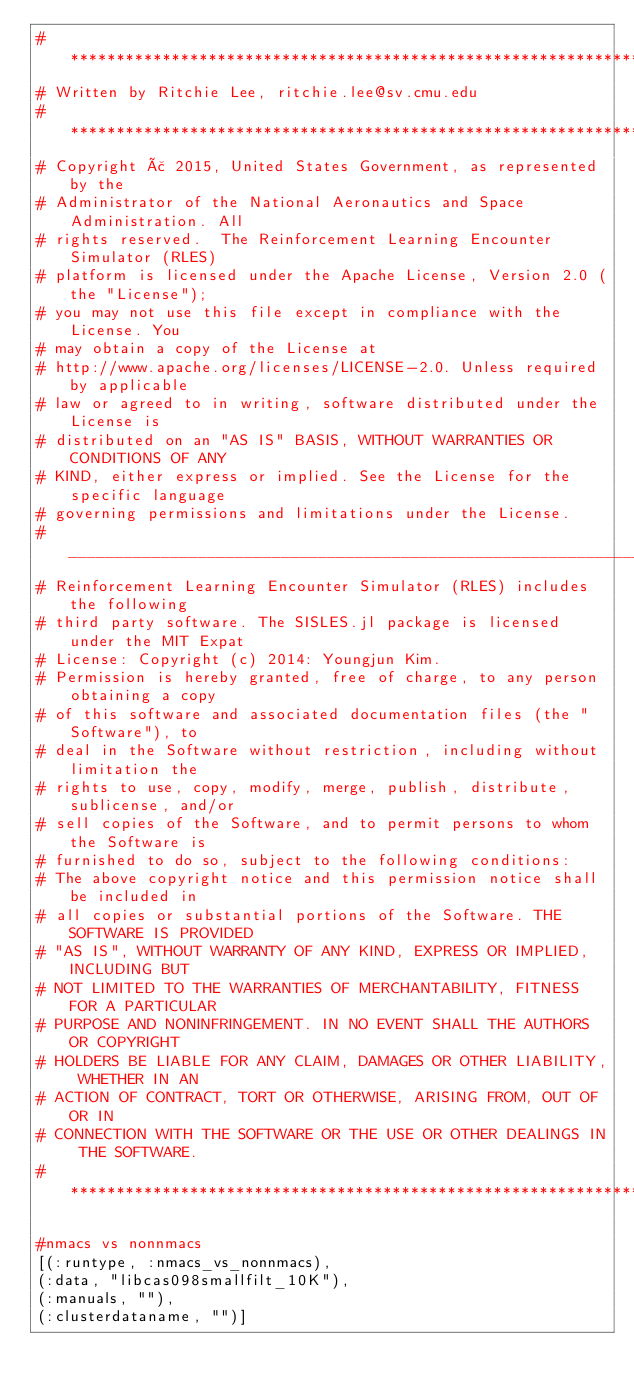<code> <loc_0><loc_0><loc_500><loc_500><_Julia_># *****************************************************************************
# Written by Ritchie Lee, ritchie.lee@sv.cmu.edu
# *****************************************************************************
# Copyright ã 2015, United States Government, as represented by the
# Administrator of the National Aeronautics and Space Administration. All
# rights reserved.  The Reinforcement Learning Encounter Simulator (RLES)
# platform is licensed under the Apache License, Version 2.0 (the "License");
# you may not use this file except in compliance with the License. You
# may obtain a copy of the License at
# http://www.apache.org/licenses/LICENSE-2.0. Unless required by applicable
# law or agreed to in writing, software distributed under the License is
# distributed on an "AS IS" BASIS, WITHOUT WARRANTIES OR CONDITIONS OF ANY
# KIND, either express or implied. See the License for the specific language
# governing permissions and limitations under the License.
# _____________________________________________________________________________
# Reinforcement Learning Encounter Simulator (RLES) includes the following
# third party software. The SISLES.jl package is licensed under the MIT Expat
# License: Copyright (c) 2014: Youngjun Kim.
# Permission is hereby granted, free of charge, to any person obtaining a copy
# of this software and associated documentation files (the "Software"), to
# deal in the Software without restriction, including without limitation the
# rights to use, copy, modify, merge, publish, distribute, sublicense, and/or
# sell copies of the Software, and to permit persons to whom the Software is
# furnished to do so, subject to the following conditions:
# The above copyright notice and this permission notice shall be included in
# all copies or substantial portions of the Software. THE SOFTWARE IS PROVIDED
# "AS IS", WITHOUT WARRANTY OF ANY KIND, EXPRESS OR IMPLIED, INCLUDING BUT
# NOT LIMITED TO THE WARRANTIES OF MERCHANTABILITY, FITNESS FOR A PARTICULAR
# PURPOSE AND NONINFRINGEMENT. IN NO EVENT SHALL THE AUTHORS OR COPYRIGHT
# HOLDERS BE LIABLE FOR ANY CLAIM, DAMAGES OR OTHER LIABILITY, WHETHER IN AN
# ACTION OF CONTRACT, TORT OR OTHERWISE, ARISING FROM, OUT OF OR IN
# CONNECTION WITH THE SOFTWARE OR THE USE OR OTHER DEALINGS IN THE SOFTWARE.
# *****************************************************************************

#nmacs vs nonnmacs
[(:runtype, :nmacs_vs_nonnmacs),
(:data, "libcas098smallfilt_10K"),
(:manuals, ""),
(:clusterdataname, "")]


</code> 